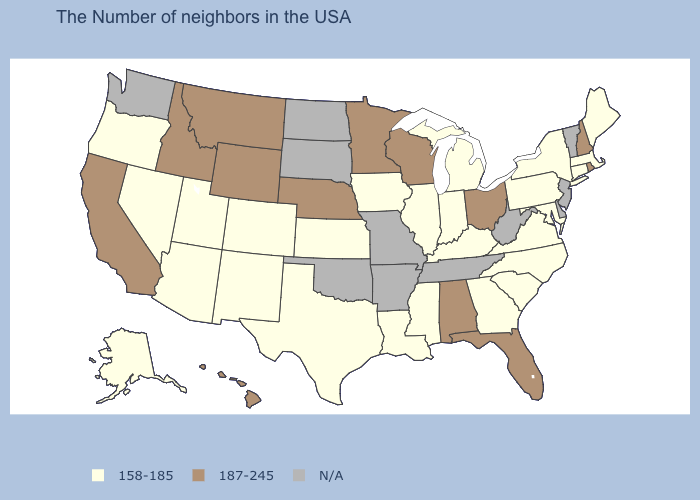Does Massachusetts have the highest value in the USA?
Short answer required. No. Which states have the highest value in the USA?
Keep it brief. Rhode Island, New Hampshire, Ohio, Florida, Alabama, Wisconsin, Minnesota, Nebraska, Wyoming, Montana, Idaho, California, Hawaii. Is the legend a continuous bar?
Write a very short answer. No. Among the states that border Arkansas , which have the highest value?
Be succinct. Mississippi, Louisiana, Texas. What is the highest value in the West ?
Answer briefly. 187-245. Does Florida have the highest value in the USA?
Keep it brief. Yes. Name the states that have a value in the range N/A?
Concise answer only. Vermont, New Jersey, Delaware, West Virginia, Tennessee, Missouri, Arkansas, Oklahoma, South Dakota, North Dakota, Washington. Does Florida have the lowest value in the South?
Concise answer only. No. Among the states that border Delaware , which have the lowest value?
Short answer required. Maryland, Pennsylvania. Does the map have missing data?
Keep it brief. Yes. Name the states that have a value in the range N/A?
Quick response, please. Vermont, New Jersey, Delaware, West Virginia, Tennessee, Missouri, Arkansas, Oklahoma, South Dakota, North Dakota, Washington. Among the states that border Maine , which have the lowest value?
Concise answer only. New Hampshire. Does Hawaii have the lowest value in the USA?
Be succinct. No. 